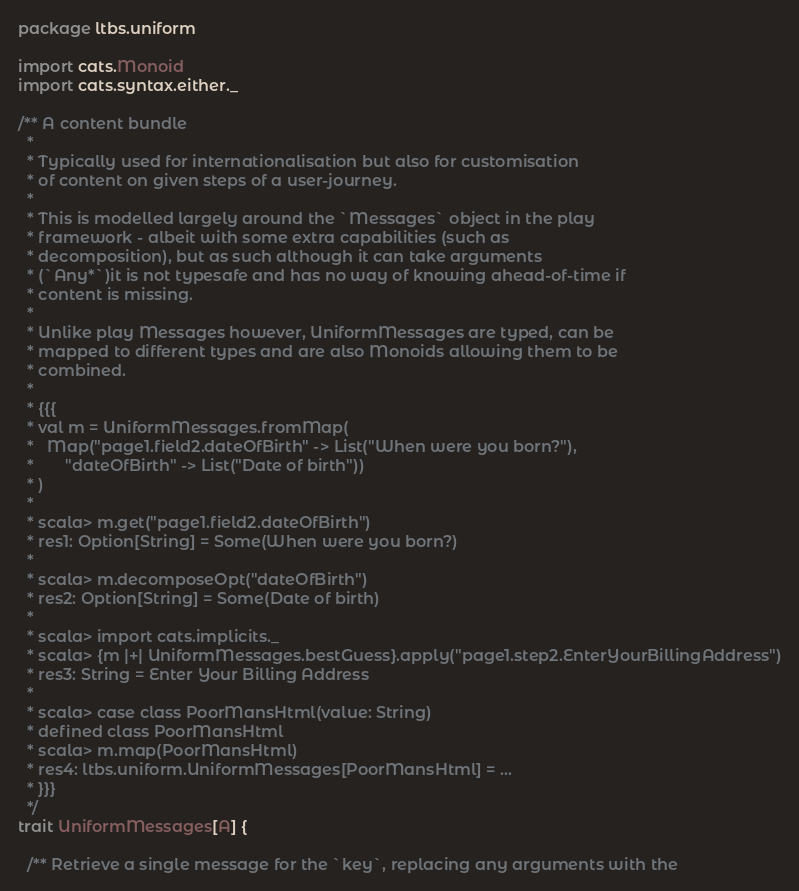Convert code to text. <code><loc_0><loc_0><loc_500><loc_500><_Scala_>package ltbs.uniform

import cats.Monoid
import cats.syntax.either._

/** A content bundle
  * 
  * Typically used for internationalisation but also for customisation
  * of content on given steps of a user-journey. 
  * 
  * This is modelled largely around the `Messages` object in the play
  * framework - albeit with some extra capabilities (such as
  * decomposition), but as such although it can take arguments
  * (`Any*`)it is not typesafe and has no way of knowing ahead-of-time if
  * content is missing.  
  * 
  * Unlike play Messages however, UniformMessages are typed, can be
  * mapped to different types and are also Monoids allowing them to be
  * combined. 
  * 
  * {{{
  * val m = UniformMessages.fromMap(
  *   Map("page1.field2.dateOfBirth" -> List("When were you born?"), 
  *       "dateOfBirth" -> List("Date of birth"))
  * )
  * 
  * scala> m.get("page1.field2.dateOfBirth")
  * res1: Option[String] = Some(When were you born?)
  * 
  * scala> m.decomposeOpt("dateOfBirth")
  * res2: Option[String] = Some(Date of birth)
  * 
  * scala> import cats.implicits._
  * scala> {m |+| UniformMessages.bestGuess}.apply("page1.step2.EnterYourBillingAddress")
  * res3: String = Enter Your Billing Address
  * 
  * scala> case class PoorMansHtml(value: String)
  * defined class PoorMansHtml
  * scala> m.map(PoorMansHtml)
  * res4: ltbs.uniform.UniformMessages[PoorMansHtml] = ...
  * }}}
  */
trait UniformMessages[A] {

  /** Retrieve a single message for the `key`, replacing any arguments with the</code> 